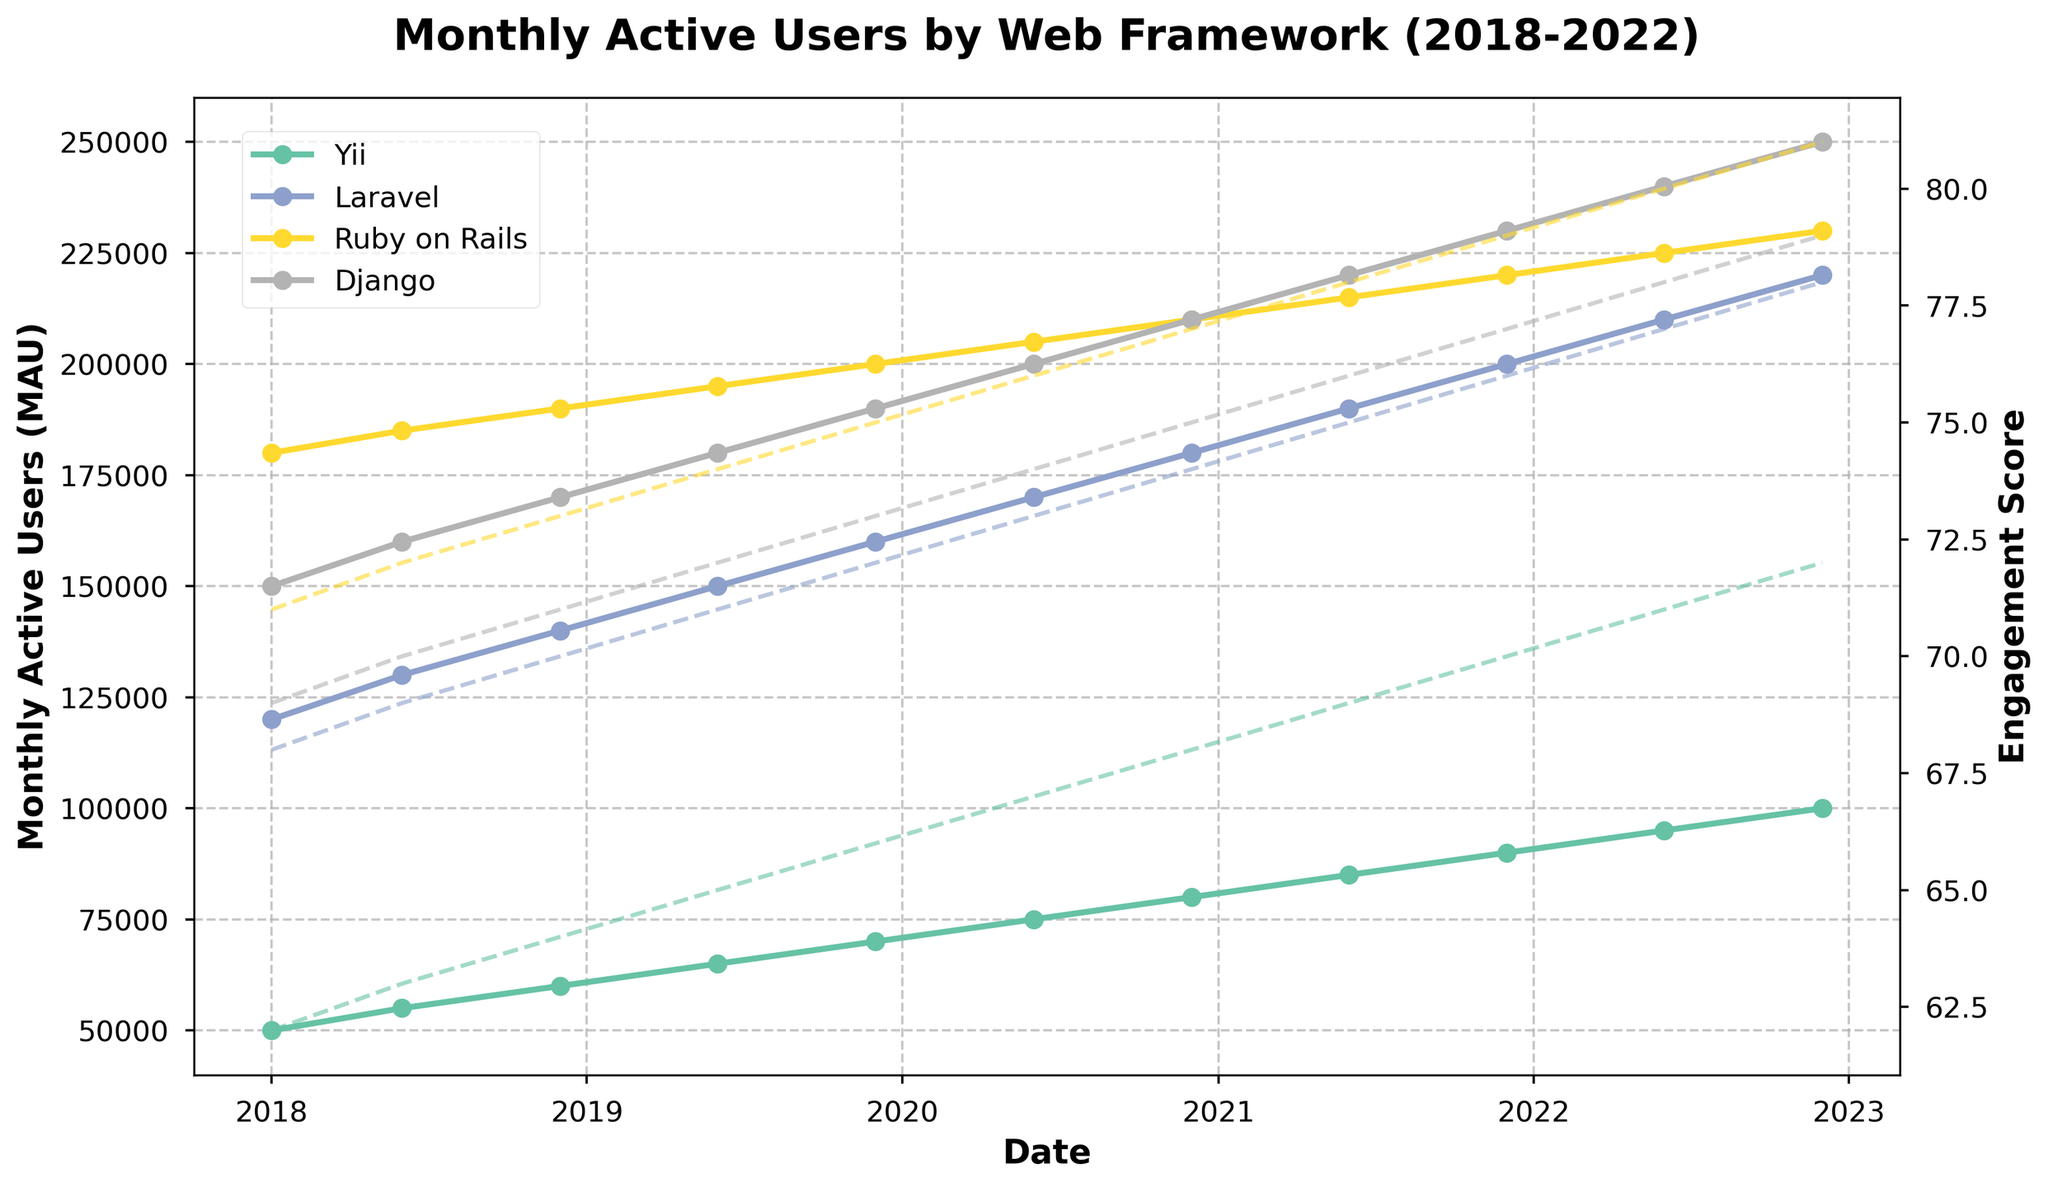Which web framework had the highest Monthly Active Users (MAU) in 2022? Look for the highest point on the MAU axis for the year 2022 and note the corresponding framework.
Answer: Django How did the Monthly Active Users (MAU) for Yii change from January 2018 to December 2022? Identify the MAU for Yii in January 2018 and compare it with the MAU for Yii in December 2022 to see the change.
Answer: Increased Between Laravel and Ruby on Rails, which had a higher Engagement Score in December 2020? Locate the points for Laravel and Ruby on Rails in December 2020 on the Engagement Score axis and compare their heights.
Answer: Ruby on Rails Which framework showed the most consistent increase in MAU from 2018 to 2022? Identify which framework's MAU line rises consistently from 2018 to 2022 without significant drops.
Answer: Django What is the average MAU for Yii in December of each year from 2018 to 2022? Compute the average of MAU values for Yii in December 2018, 2019, 2020, 2021, and 2022.
Answer: 80,000 Comparing first halves (June) versus the second halves (December) of each year, did Django's Engagement Score generally increase, decrease, or remain unchanged? Compare the Engagement Scores of Django between June and December of each year from 2018 to 2022 to see the trend.
Answer: Increased Which framework had the lowest Engagement Score in June 2019, and what was that score? Locate the Engagement Scores for each framework in June 2019 and identify the lowest score and corresponding framework.
Answer: Yii, 65 From 2018 to 2022, which framework had the sharpest increase in MAU in any single year, and what was the value difference? Calculate the year-to-year difference in MAU for each framework and find the highest difference.
Answer: Django, 40,000 (2021-2022) How does the Engagement Score trend for Yii compare to that of Laravel from 2018 to 2022? Examine the slope trends of both Yii and Laravel's Engagement Score lines to see if they are increasing, decreasing, or stable.
Answer: Both increased Which year showed the largest overall increase in MAU across all frameworks combined? Sum the MAU for all frameworks for each year and identify which year has the biggest difference from the previous year.
Answer: 2020 